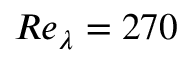<formula> <loc_0><loc_0><loc_500><loc_500>R e _ { \lambda } = 2 7 0</formula> 